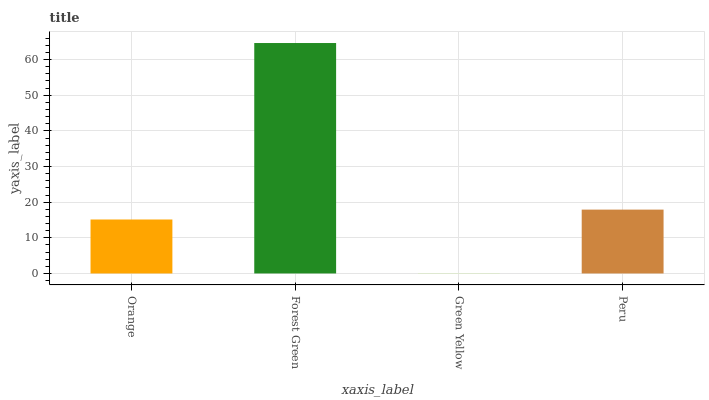Is Green Yellow the minimum?
Answer yes or no. Yes. Is Forest Green the maximum?
Answer yes or no. Yes. Is Forest Green the minimum?
Answer yes or no. No. Is Green Yellow the maximum?
Answer yes or no. No. Is Forest Green greater than Green Yellow?
Answer yes or no. Yes. Is Green Yellow less than Forest Green?
Answer yes or no. Yes. Is Green Yellow greater than Forest Green?
Answer yes or no. No. Is Forest Green less than Green Yellow?
Answer yes or no. No. Is Peru the high median?
Answer yes or no. Yes. Is Orange the low median?
Answer yes or no. Yes. Is Forest Green the high median?
Answer yes or no. No. Is Green Yellow the low median?
Answer yes or no. No. 